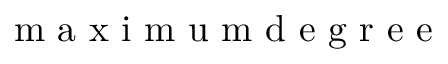Convert formula to latex. <formula><loc_0><loc_0><loc_500><loc_500>m a x i m u m d e g r e e</formula> 